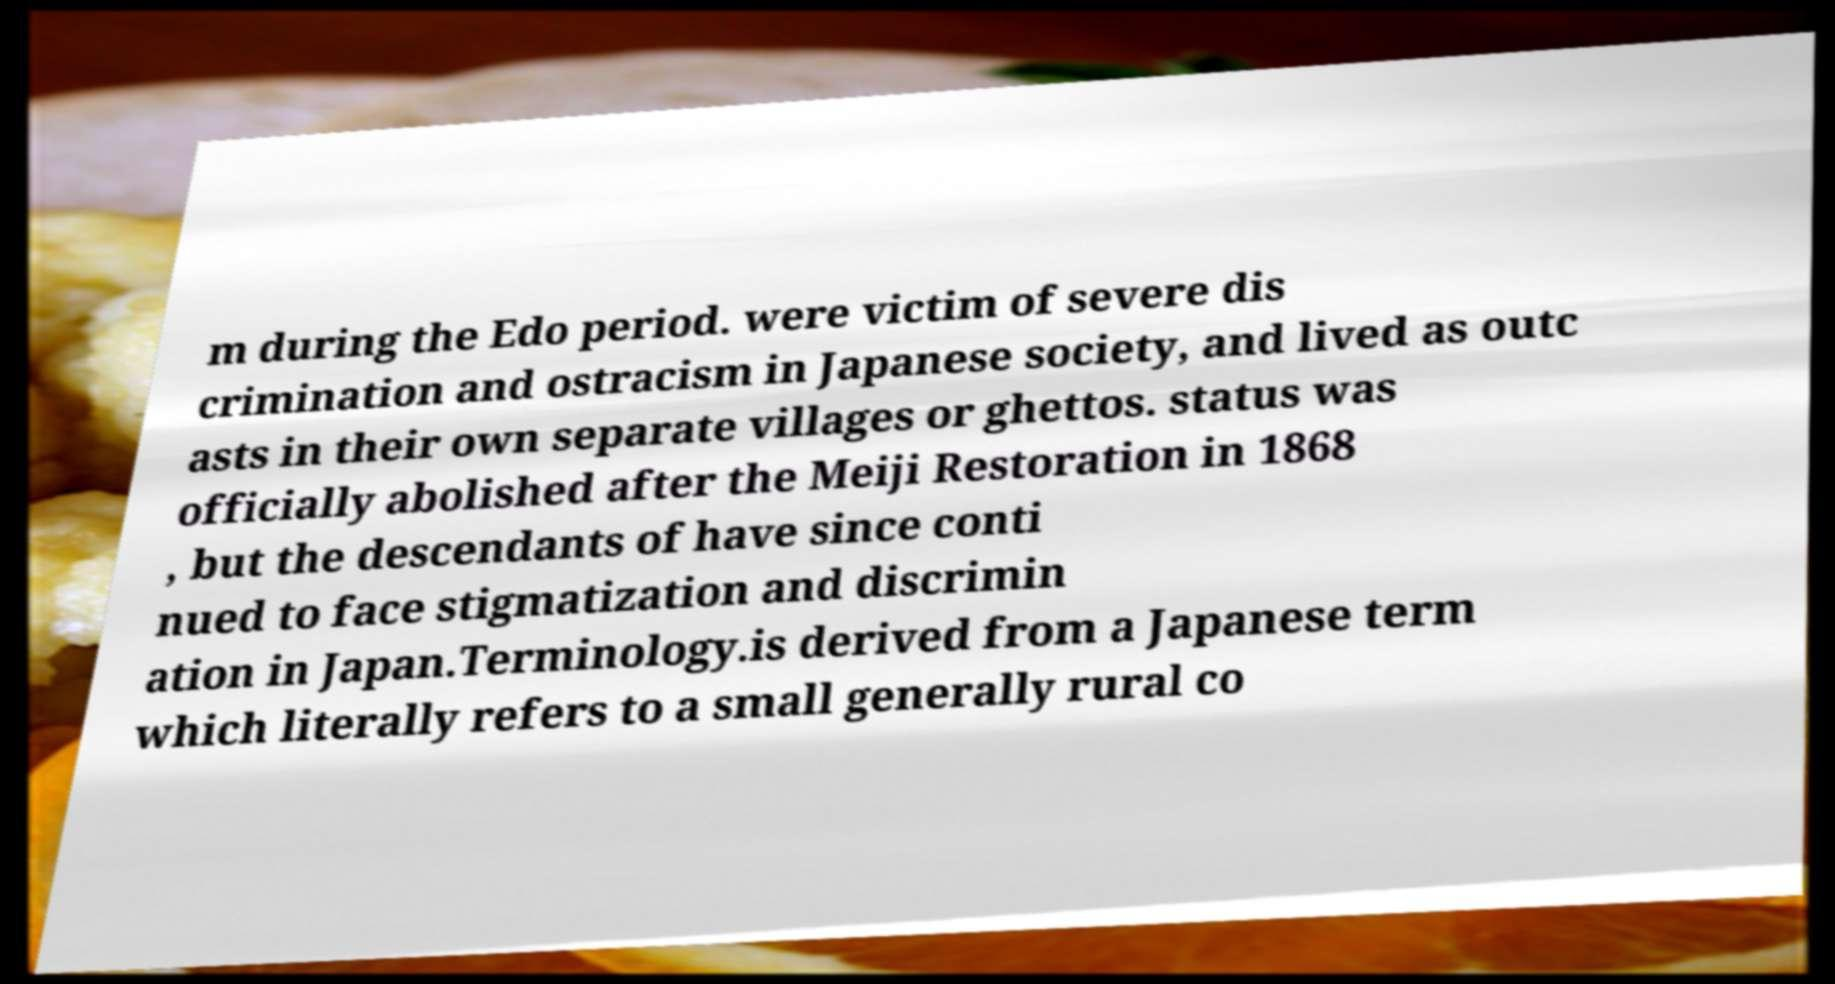Please read and relay the text visible in this image. What does it say? m during the Edo period. were victim of severe dis crimination and ostracism in Japanese society, and lived as outc asts in their own separate villages or ghettos. status was officially abolished after the Meiji Restoration in 1868 , but the descendants of have since conti nued to face stigmatization and discrimin ation in Japan.Terminology.is derived from a Japanese term which literally refers to a small generally rural co 